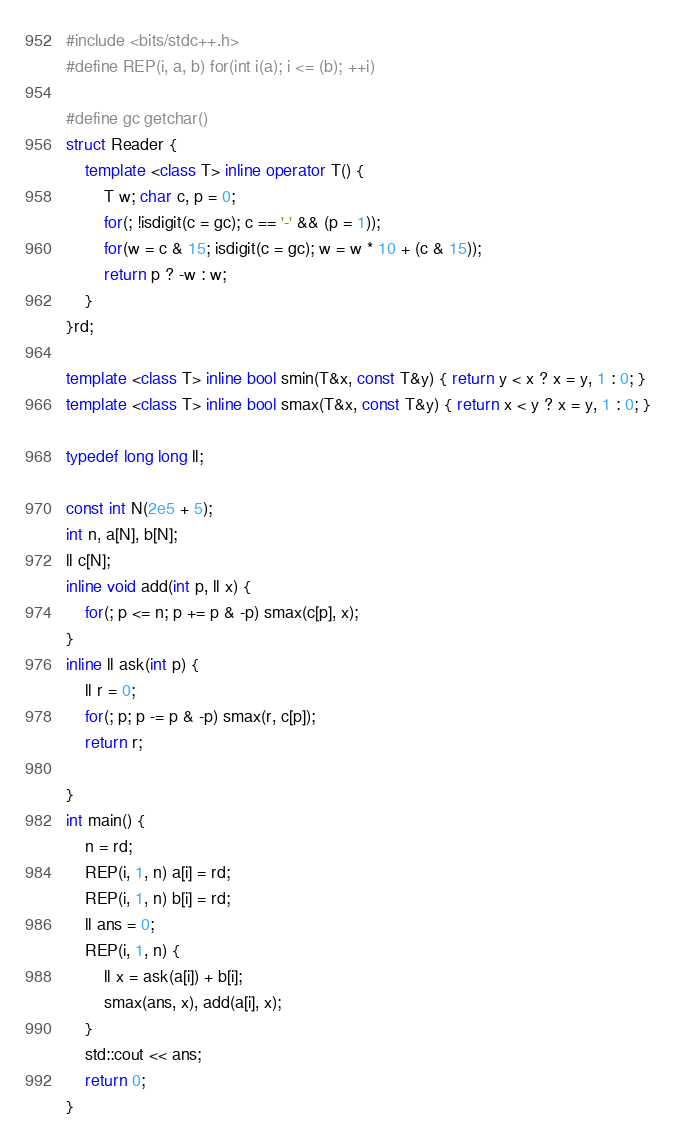Convert code to text. <code><loc_0><loc_0><loc_500><loc_500><_C++_>#include <bits/stdc++.h>
#define REP(i, a, b) for(int i(a); i <= (b); ++i)

#define gc getchar()
struct Reader {
	template <class T> inline operator T() {
		T w; char c, p = 0;
		for(; !isdigit(c = gc); c == '-' && (p = 1));
		for(w = c & 15; isdigit(c = gc); w = w * 10 + (c & 15));
		return p ? -w : w;
	}
}rd;

template <class T> inline bool smin(T&x, const T&y) { return y < x ? x = y, 1 : 0; }
template <class T> inline bool smax(T&x, const T&y) { return x < y ? x = y, 1 : 0; }

typedef long long ll;

const int N(2e5 + 5);
int n, a[N], b[N];
ll c[N];
inline void add(int p, ll x) {
	for(; p <= n; p += p & -p) smax(c[p], x);
}
inline ll ask(int p) {
	ll r = 0;
	for(; p; p -= p & -p) smax(r, c[p]);
	return r;
	
}
int main() {
	n = rd;
	REP(i, 1, n) a[i] = rd;
	REP(i, 1, n) b[i] = rd;
	ll ans = 0;
	REP(i, 1, n) {
		ll x = ask(a[i]) + b[i];
		smax(ans, x), add(a[i], x);
	}
	std::cout << ans;
	return 0;
}

</code> 